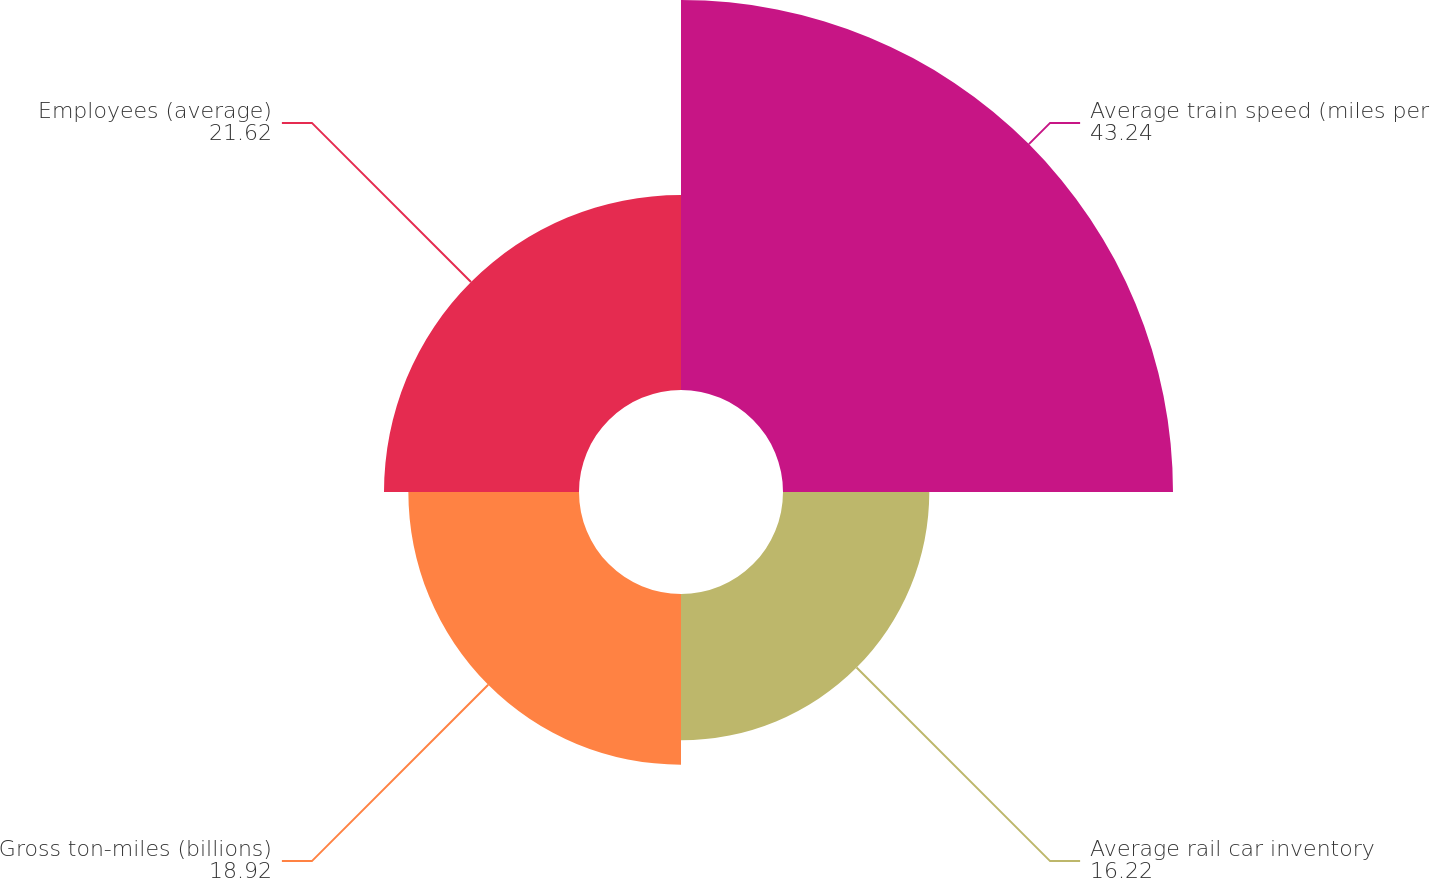Convert chart to OTSL. <chart><loc_0><loc_0><loc_500><loc_500><pie_chart><fcel>Average train speed (miles per<fcel>Average rail car inventory<fcel>Gross ton-miles (billions)<fcel>Employees (average)<nl><fcel>43.24%<fcel>16.22%<fcel>18.92%<fcel>21.62%<nl></chart> 